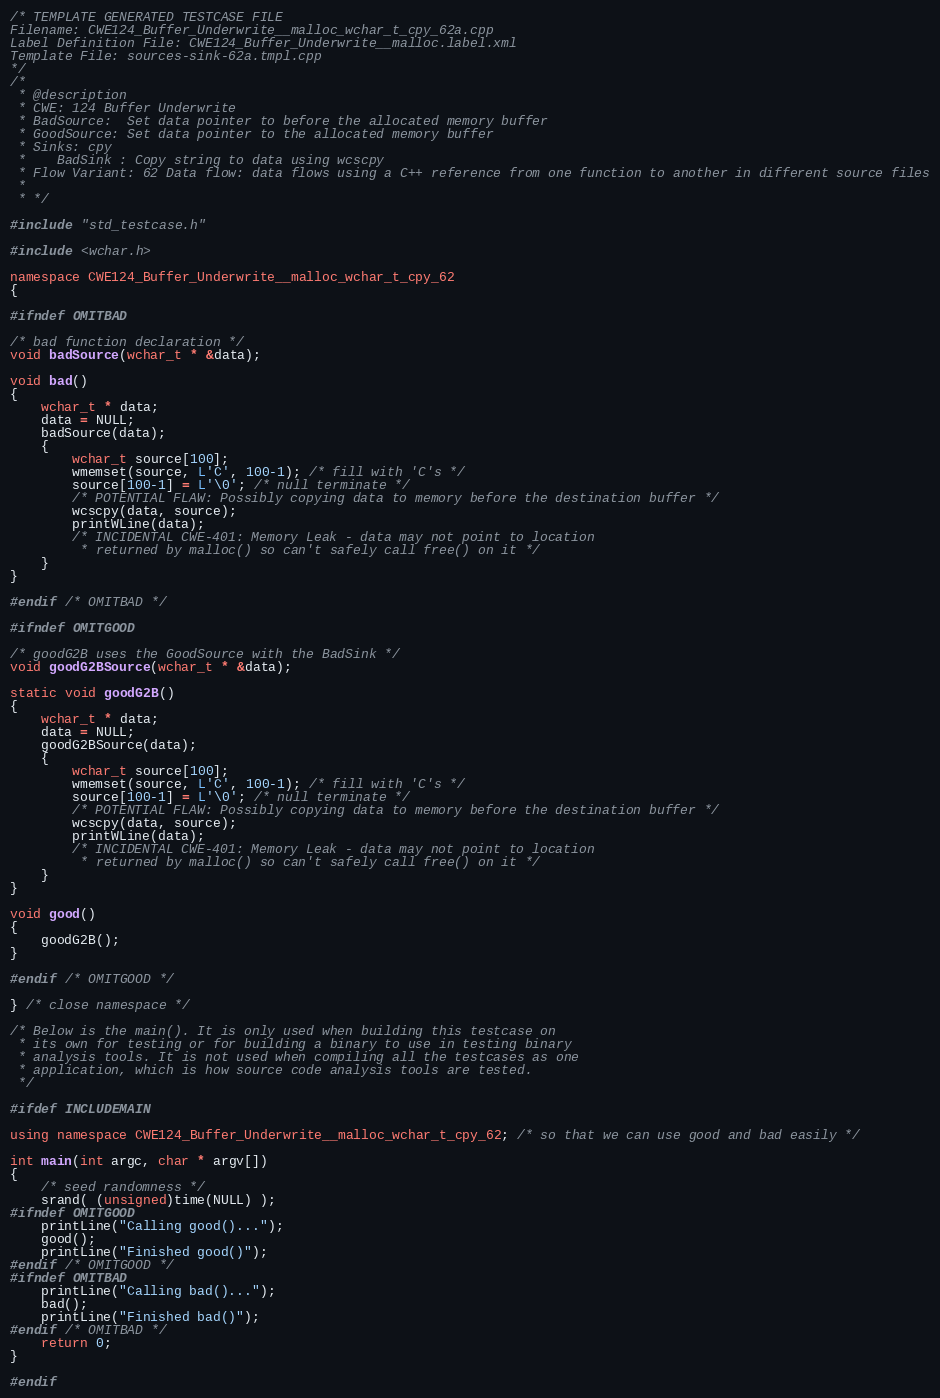<code> <loc_0><loc_0><loc_500><loc_500><_C++_>/* TEMPLATE GENERATED TESTCASE FILE
Filename: CWE124_Buffer_Underwrite__malloc_wchar_t_cpy_62a.cpp
Label Definition File: CWE124_Buffer_Underwrite__malloc.label.xml
Template File: sources-sink-62a.tmpl.cpp
*/
/*
 * @description
 * CWE: 124 Buffer Underwrite
 * BadSource:  Set data pointer to before the allocated memory buffer
 * GoodSource: Set data pointer to the allocated memory buffer
 * Sinks: cpy
 *    BadSink : Copy string to data using wcscpy
 * Flow Variant: 62 Data flow: data flows using a C++ reference from one function to another in different source files
 *
 * */

#include "std_testcase.h"

#include <wchar.h>

namespace CWE124_Buffer_Underwrite__malloc_wchar_t_cpy_62
{

#ifndef OMITBAD

/* bad function declaration */
void badSource(wchar_t * &data);

void bad()
{
    wchar_t * data;
    data = NULL;
    badSource(data);
    {
        wchar_t source[100];
        wmemset(source, L'C', 100-1); /* fill with 'C's */
        source[100-1] = L'\0'; /* null terminate */
        /* POTENTIAL FLAW: Possibly copying data to memory before the destination buffer */
        wcscpy(data, source);
        printWLine(data);
        /* INCIDENTAL CWE-401: Memory Leak - data may not point to location
         * returned by malloc() so can't safely call free() on it */
    }
}

#endif /* OMITBAD */

#ifndef OMITGOOD

/* goodG2B uses the GoodSource with the BadSink */
void goodG2BSource(wchar_t * &data);

static void goodG2B()
{
    wchar_t * data;
    data = NULL;
    goodG2BSource(data);
    {
        wchar_t source[100];
        wmemset(source, L'C', 100-1); /* fill with 'C's */
        source[100-1] = L'\0'; /* null terminate */
        /* POTENTIAL FLAW: Possibly copying data to memory before the destination buffer */
        wcscpy(data, source);
        printWLine(data);
        /* INCIDENTAL CWE-401: Memory Leak - data may not point to location
         * returned by malloc() so can't safely call free() on it */
    }
}

void good()
{
    goodG2B();
}

#endif /* OMITGOOD */

} /* close namespace */

/* Below is the main(). It is only used when building this testcase on
 * its own for testing or for building a binary to use in testing binary
 * analysis tools. It is not used when compiling all the testcases as one
 * application, which is how source code analysis tools are tested.
 */

#ifdef INCLUDEMAIN

using namespace CWE124_Buffer_Underwrite__malloc_wchar_t_cpy_62; /* so that we can use good and bad easily */

int main(int argc, char * argv[])
{
    /* seed randomness */
    srand( (unsigned)time(NULL) );
#ifndef OMITGOOD
    printLine("Calling good()...");
    good();
    printLine("Finished good()");
#endif /* OMITGOOD */
#ifndef OMITBAD
    printLine("Calling bad()...");
    bad();
    printLine("Finished bad()");
#endif /* OMITBAD */
    return 0;
}

#endif
</code> 